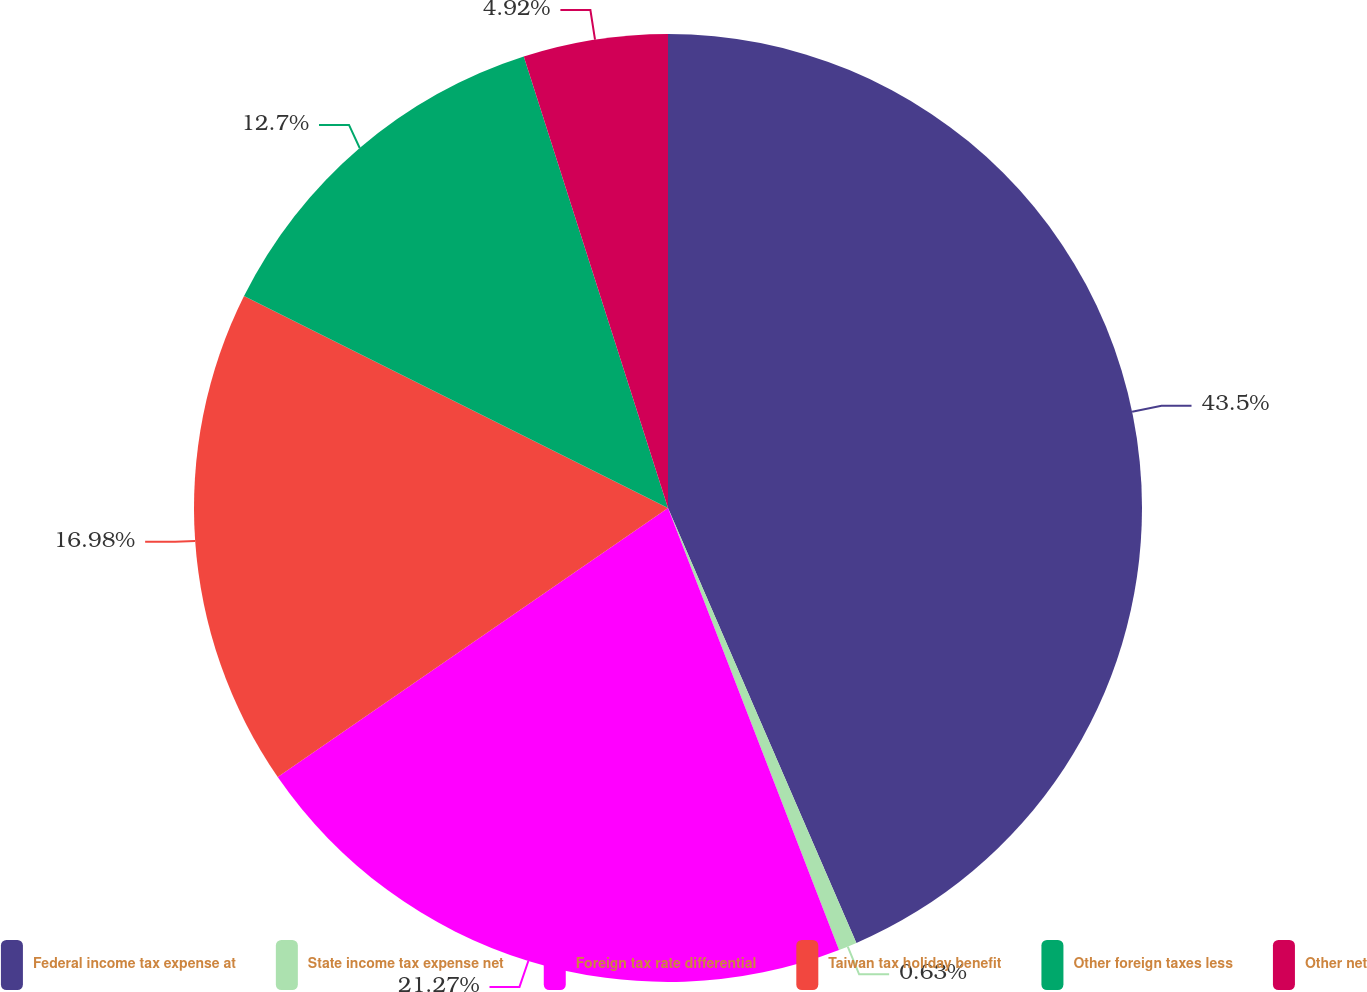<chart> <loc_0><loc_0><loc_500><loc_500><pie_chart><fcel>Federal income tax expense at<fcel>State income tax expense net<fcel>Foreign tax rate differential<fcel>Taiwan tax holiday benefit<fcel>Other foreign taxes less<fcel>Other net<nl><fcel>43.49%<fcel>0.63%<fcel>21.27%<fcel>16.98%<fcel>12.7%<fcel>4.92%<nl></chart> 